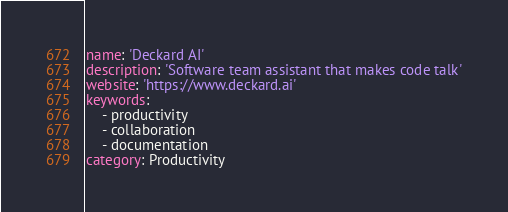<code> <loc_0><loc_0><loc_500><loc_500><_YAML_>name: 'Deckard AI'
description: 'Software team assistant that makes code talk'
website: 'https://www.deckard.ai'
keywords:
    - productivity
    - collaboration
    - documentation
category: Productivity
</code> 